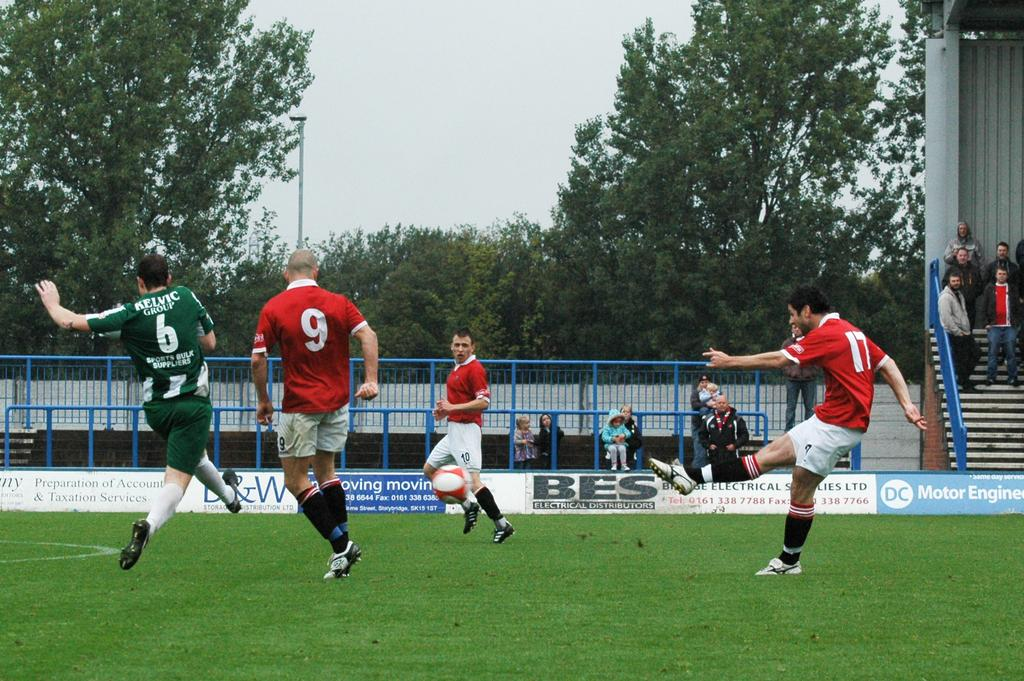<image>
Relay a brief, clear account of the picture shown. A soccer player wearing number 17 kicks a ball. 